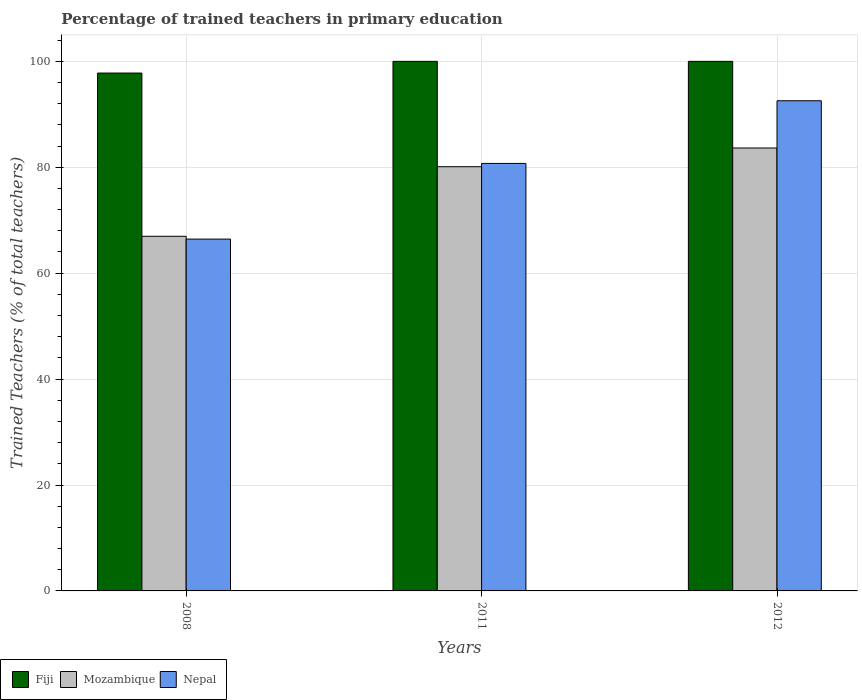How many different coloured bars are there?
Provide a short and direct response. 3. Are the number of bars per tick equal to the number of legend labels?
Make the answer very short. Yes. How many bars are there on the 1st tick from the left?
Provide a short and direct response. 3. What is the label of the 2nd group of bars from the left?
Give a very brief answer. 2011. Across all years, what is the maximum percentage of trained teachers in Mozambique?
Offer a very short reply. 83.64. Across all years, what is the minimum percentage of trained teachers in Mozambique?
Your answer should be very brief. 66.97. In which year was the percentage of trained teachers in Mozambique maximum?
Offer a terse response. 2012. What is the total percentage of trained teachers in Fiji in the graph?
Offer a very short reply. 297.79. What is the difference between the percentage of trained teachers in Fiji in 2008 and that in 2012?
Make the answer very short. -2.21. What is the difference between the percentage of trained teachers in Mozambique in 2011 and the percentage of trained teachers in Nepal in 2012?
Offer a very short reply. -12.46. What is the average percentage of trained teachers in Nepal per year?
Keep it short and to the point. 79.91. In the year 2008, what is the difference between the percentage of trained teachers in Mozambique and percentage of trained teachers in Nepal?
Ensure brevity in your answer.  0.53. What is the ratio of the percentage of trained teachers in Nepal in 2011 to that in 2012?
Offer a terse response. 0.87. Is the percentage of trained teachers in Mozambique in 2011 less than that in 2012?
Your response must be concise. Yes. Is the difference between the percentage of trained teachers in Mozambique in 2008 and 2012 greater than the difference between the percentage of trained teachers in Nepal in 2008 and 2012?
Provide a succinct answer. Yes. What is the difference between the highest and the second highest percentage of trained teachers in Nepal?
Your answer should be very brief. 11.83. What is the difference between the highest and the lowest percentage of trained teachers in Nepal?
Make the answer very short. 26.12. In how many years, is the percentage of trained teachers in Fiji greater than the average percentage of trained teachers in Fiji taken over all years?
Offer a very short reply. 2. Is the sum of the percentage of trained teachers in Fiji in 2008 and 2011 greater than the maximum percentage of trained teachers in Nepal across all years?
Ensure brevity in your answer.  Yes. What does the 2nd bar from the left in 2008 represents?
Offer a very short reply. Mozambique. What does the 1st bar from the right in 2011 represents?
Your response must be concise. Nepal. Is it the case that in every year, the sum of the percentage of trained teachers in Mozambique and percentage of trained teachers in Fiji is greater than the percentage of trained teachers in Nepal?
Give a very brief answer. Yes. Are all the bars in the graph horizontal?
Provide a succinct answer. No. How many years are there in the graph?
Your response must be concise. 3. What is the difference between two consecutive major ticks on the Y-axis?
Offer a terse response. 20. How many legend labels are there?
Give a very brief answer. 3. How are the legend labels stacked?
Offer a terse response. Horizontal. What is the title of the graph?
Provide a succinct answer. Percentage of trained teachers in primary education. What is the label or title of the Y-axis?
Ensure brevity in your answer.  Trained Teachers (% of total teachers). What is the Trained Teachers (% of total teachers) of Fiji in 2008?
Give a very brief answer. 97.79. What is the Trained Teachers (% of total teachers) in Mozambique in 2008?
Give a very brief answer. 66.97. What is the Trained Teachers (% of total teachers) in Nepal in 2008?
Provide a succinct answer. 66.44. What is the Trained Teachers (% of total teachers) in Fiji in 2011?
Provide a short and direct response. 100. What is the Trained Teachers (% of total teachers) in Mozambique in 2011?
Offer a very short reply. 80.1. What is the Trained Teachers (% of total teachers) in Nepal in 2011?
Give a very brief answer. 80.73. What is the Trained Teachers (% of total teachers) in Fiji in 2012?
Ensure brevity in your answer.  100. What is the Trained Teachers (% of total teachers) in Mozambique in 2012?
Offer a very short reply. 83.64. What is the Trained Teachers (% of total teachers) of Nepal in 2012?
Ensure brevity in your answer.  92.56. Across all years, what is the maximum Trained Teachers (% of total teachers) in Mozambique?
Your response must be concise. 83.64. Across all years, what is the maximum Trained Teachers (% of total teachers) in Nepal?
Your answer should be very brief. 92.56. Across all years, what is the minimum Trained Teachers (% of total teachers) of Fiji?
Offer a very short reply. 97.79. Across all years, what is the minimum Trained Teachers (% of total teachers) of Mozambique?
Give a very brief answer. 66.97. Across all years, what is the minimum Trained Teachers (% of total teachers) of Nepal?
Provide a short and direct response. 66.44. What is the total Trained Teachers (% of total teachers) of Fiji in the graph?
Your response must be concise. 297.79. What is the total Trained Teachers (% of total teachers) in Mozambique in the graph?
Your answer should be compact. 230.71. What is the total Trained Teachers (% of total teachers) of Nepal in the graph?
Make the answer very short. 239.72. What is the difference between the Trained Teachers (% of total teachers) in Fiji in 2008 and that in 2011?
Your answer should be very brief. -2.21. What is the difference between the Trained Teachers (% of total teachers) of Mozambique in 2008 and that in 2011?
Your answer should be compact. -13.14. What is the difference between the Trained Teachers (% of total teachers) in Nepal in 2008 and that in 2011?
Offer a terse response. -14.29. What is the difference between the Trained Teachers (% of total teachers) in Fiji in 2008 and that in 2012?
Your answer should be very brief. -2.21. What is the difference between the Trained Teachers (% of total teachers) in Mozambique in 2008 and that in 2012?
Offer a terse response. -16.67. What is the difference between the Trained Teachers (% of total teachers) in Nepal in 2008 and that in 2012?
Offer a very short reply. -26.12. What is the difference between the Trained Teachers (% of total teachers) of Mozambique in 2011 and that in 2012?
Your answer should be compact. -3.54. What is the difference between the Trained Teachers (% of total teachers) of Nepal in 2011 and that in 2012?
Offer a very short reply. -11.83. What is the difference between the Trained Teachers (% of total teachers) of Fiji in 2008 and the Trained Teachers (% of total teachers) of Mozambique in 2011?
Offer a very short reply. 17.69. What is the difference between the Trained Teachers (% of total teachers) in Fiji in 2008 and the Trained Teachers (% of total teachers) in Nepal in 2011?
Provide a succinct answer. 17.06. What is the difference between the Trained Teachers (% of total teachers) of Mozambique in 2008 and the Trained Teachers (% of total teachers) of Nepal in 2011?
Give a very brief answer. -13.76. What is the difference between the Trained Teachers (% of total teachers) of Fiji in 2008 and the Trained Teachers (% of total teachers) of Mozambique in 2012?
Make the answer very short. 14.15. What is the difference between the Trained Teachers (% of total teachers) in Fiji in 2008 and the Trained Teachers (% of total teachers) in Nepal in 2012?
Provide a short and direct response. 5.23. What is the difference between the Trained Teachers (% of total teachers) in Mozambique in 2008 and the Trained Teachers (% of total teachers) in Nepal in 2012?
Make the answer very short. -25.59. What is the difference between the Trained Teachers (% of total teachers) in Fiji in 2011 and the Trained Teachers (% of total teachers) in Mozambique in 2012?
Keep it short and to the point. 16.36. What is the difference between the Trained Teachers (% of total teachers) of Fiji in 2011 and the Trained Teachers (% of total teachers) of Nepal in 2012?
Make the answer very short. 7.44. What is the difference between the Trained Teachers (% of total teachers) of Mozambique in 2011 and the Trained Teachers (% of total teachers) of Nepal in 2012?
Your response must be concise. -12.46. What is the average Trained Teachers (% of total teachers) in Fiji per year?
Offer a terse response. 99.26. What is the average Trained Teachers (% of total teachers) in Mozambique per year?
Provide a short and direct response. 76.9. What is the average Trained Teachers (% of total teachers) of Nepal per year?
Your answer should be compact. 79.91. In the year 2008, what is the difference between the Trained Teachers (% of total teachers) in Fiji and Trained Teachers (% of total teachers) in Mozambique?
Offer a terse response. 30.82. In the year 2008, what is the difference between the Trained Teachers (% of total teachers) in Fiji and Trained Teachers (% of total teachers) in Nepal?
Make the answer very short. 31.36. In the year 2008, what is the difference between the Trained Teachers (% of total teachers) of Mozambique and Trained Teachers (% of total teachers) of Nepal?
Offer a terse response. 0.53. In the year 2011, what is the difference between the Trained Teachers (% of total teachers) in Fiji and Trained Teachers (% of total teachers) in Mozambique?
Make the answer very short. 19.9. In the year 2011, what is the difference between the Trained Teachers (% of total teachers) in Fiji and Trained Teachers (% of total teachers) in Nepal?
Make the answer very short. 19.27. In the year 2011, what is the difference between the Trained Teachers (% of total teachers) of Mozambique and Trained Teachers (% of total teachers) of Nepal?
Your answer should be compact. -0.62. In the year 2012, what is the difference between the Trained Teachers (% of total teachers) in Fiji and Trained Teachers (% of total teachers) in Mozambique?
Offer a terse response. 16.36. In the year 2012, what is the difference between the Trained Teachers (% of total teachers) of Fiji and Trained Teachers (% of total teachers) of Nepal?
Offer a terse response. 7.44. In the year 2012, what is the difference between the Trained Teachers (% of total teachers) in Mozambique and Trained Teachers (% of total teachers) in Nepal?
Provide a short and direct response. -8.92. What is the ratio of the Trained Teachers (% of total teachers) in Fiji in 2008 to that in 2011?
Your response must be concise. 0.98. What is the ratio of the Trained Teachers (% of total teachers) in Mozambique in 2008 to that in 2011?
Provide a short and direct response. 0.84. What is the ratio of the Trained Teachers (% of total teachers) of Nepal in 2008 to that in 2011?
Offer a very short reply. 0.82. What is the ratio of the Trained Teachers (% of total teachers) in Fiji in 2008 to that in 2012?
Your response must be concise. 0.98. What is the ratio of the Trained Teachers (% of total teachers) of Mozambique in 2008 to that in 2012?
Your answer should be very brief. 0.8. What is the ratio of the Trained Teachers (% of total teachers) of Nepal in 2008 to that in 2012?
Offer a terse response. 0.72. What is the ratio of the Trained Teachers (% of total teachers) in Mozambique in 2011 to that in 2012?
Give a very brief answer. 0.96. What is the ratio of the Trained Teachers (% of total teachers) of Nepal in 2011 to that in 2012?
Make the answer very short. 0.87. What is the difference between the highest and the second highest Trained Teachers (% of total teachers) of Mozambique?
Give a very brief answer. 3.54. What is the difference between the highest and the second highest Trained Teachers (% of total teachers) of Nepal?
Your response must be concise. 11.83. What is the difference between the highest and the lowest Trained Teachers (% of total teachers) in Fiji?
Your answer should be very brief. 2.21. What is the difference between the highest and the lowest Trained Teachers (% of total teachers) of Mozambique?
Offer a terse response. 16.67. What is the difference between the highest and the lowest Trained Teachers (% of total teachers) in Nepal?
Your response must be concise. 26.12. 